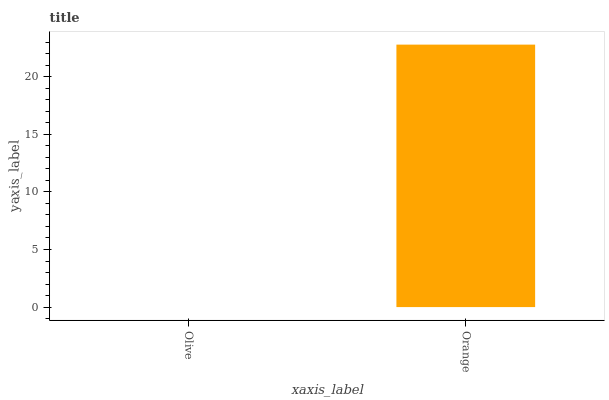Is Orange the minimum?
Answer yes or no. No. Is Orange greater than Olive?
Answer yes or no. Yes. Is Olive less than Orange?
Answer yes or no. Yes. Is Olive greater than Orange?
Answer yes or no. No. Is Orange less than Olive?
Answer yes or no. No. Is Orange the high median?
Answer yes or no. Yes. Is Olive the low median?
Answer yes or no. Yes. Is Olive the high median?
Answer yes or no. No. Is Orange the low median?
Answer yes or no. No. 